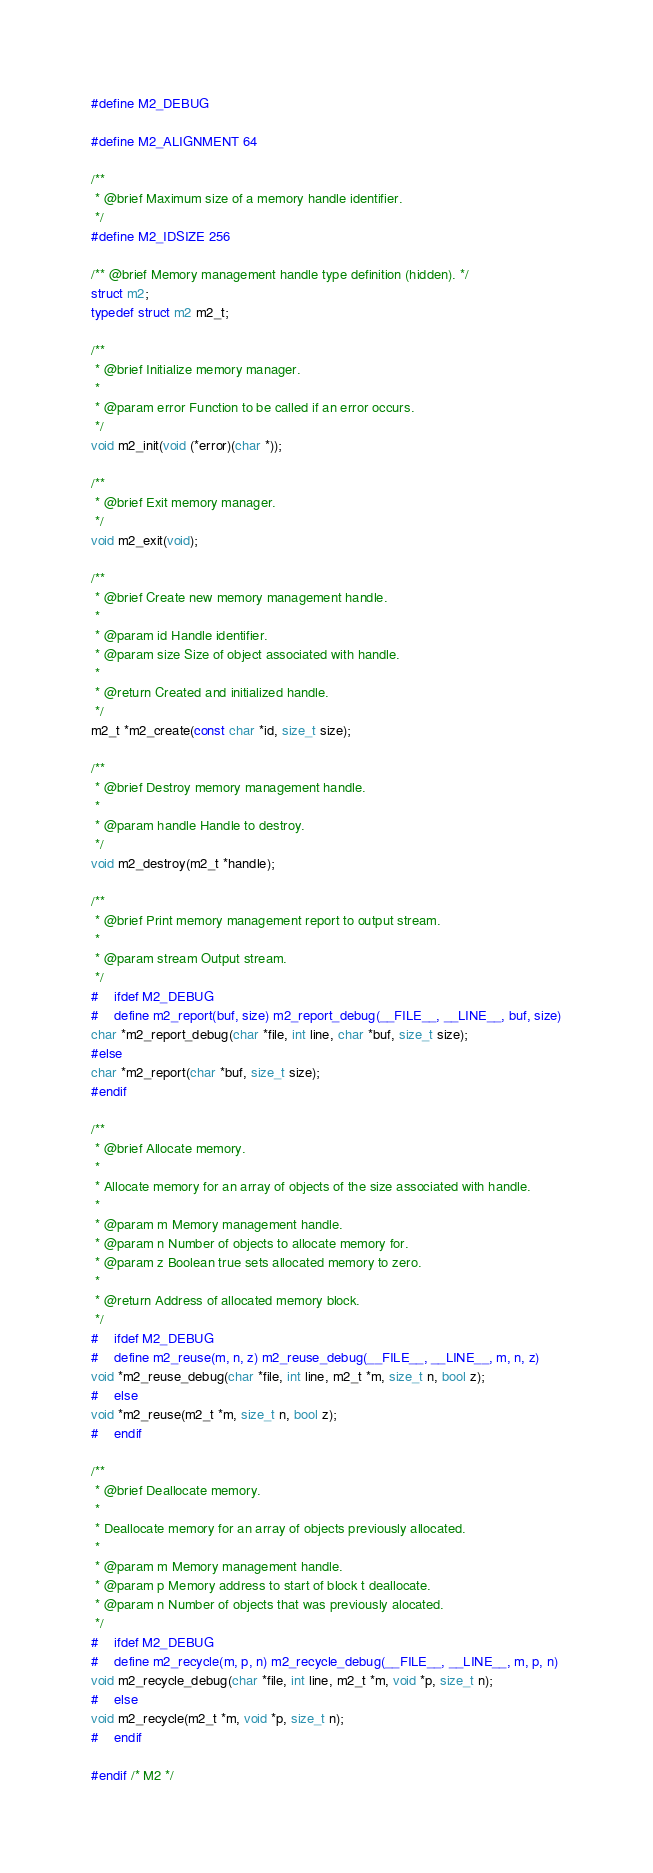Convert code to text. <code><loc_0><loc_0><loc_500><loc_500><_C_>
#define M2_DEBUG

#define M2_ALIGNMENT 64

/**
 * @brief Maximum size of a memory handle identifier.
 */
#define M2_IDSIZE 256

/** @brief Memory management handle type definition (hidden). */
struct m2;
typedef struct m2 m2_t;

/**
 * @brief Initialize memory manager.
 *
 * @param error Function to be called if an error occurs.
 */
void m2_init(void (*error)(char *));

/**
 * @brief Exit memory manager.
 */
void m2_exit(void);

/**
 * @brief Create new memory management handle.
 *
 * @param id Handle identifier.
 * @param size Size of object associated with handle.
 *
 * @return Created and initialized handle.
 */
m2_t *m2_create(const char *id, size_t size);

/**
 * @brief Destroy memory management handle.
 *
 * @param handle Handle to destroy.
 */
void m2_destroy(m2_t *handle);

/**
 * @brief Print memory management report to output stream.
 *
 * @param stream Output stream.
 */
#	ifdef M2_DEBUG
#	define m2_report(buf, size) m2_report_debug(__FILE__, __LINE__, buf, size)
char *m2_report_debug(char *file, int line, char *buf, size_t size);
#else
char *m2_report(char *buf, size_t size);
#endif

/**
 * @brief Allocate memory.
 *
 * Allocate memory for an array of objects of the size associated with handle.
 *
 * @param m Memory management handle.
 * @param n Number of objects to allocate memory for.
 * @param z Boolean true sets allocated memory to zero.
 *
 * @return Address of allocated memory block.
 */
#	ifdef M2_DEBUG
#	define m2_reuse(m, n, z) m2_reuse_debug(__FILE__, __LINE__, m, n, z)
void *m2_reuse_debug(char *file, int line, m2_t *m, size_t n, bool z);
#	else
void *m2_reuse(m2_t *m, size_t n, bool z);
#	endif

/**
 * @brief Deallocate memory.
 *
 * Deallocate memory for an array of objects previously allocated.
 *
 * @param m Memory management handle.
 * @param p Memory address to start of block t deallocate.
 * @param n Number of objects that was previously alocated.
 */
#	ifdef M2_DEBUG
#	define m2_recycle(m, p, n) m2_recycle_debug(__FILE__, __LINE__, m, p, n)
void m2_recycle_debug(char *file, int line, m2_t *m, void *p, size_t n);
#	else
void m2_recycle(m2_t *m, void *p, size_t n);
#	endif

#endif /* M2 */
</code> 